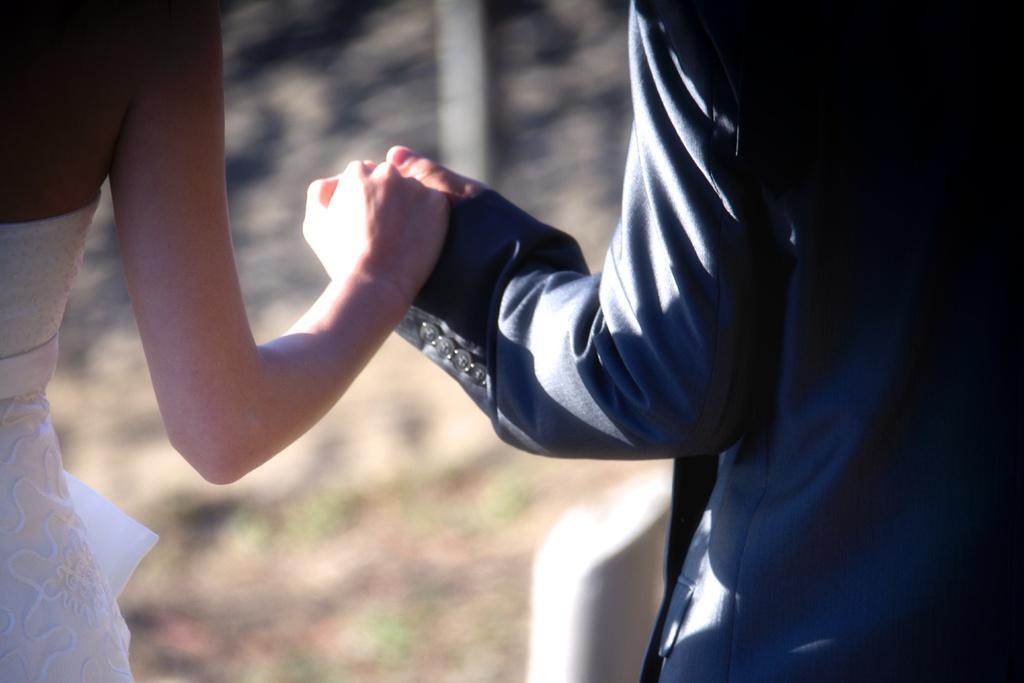In one or two sentences, can you explain what this image depicts? In this picture we can see people and there are holding their hands. 